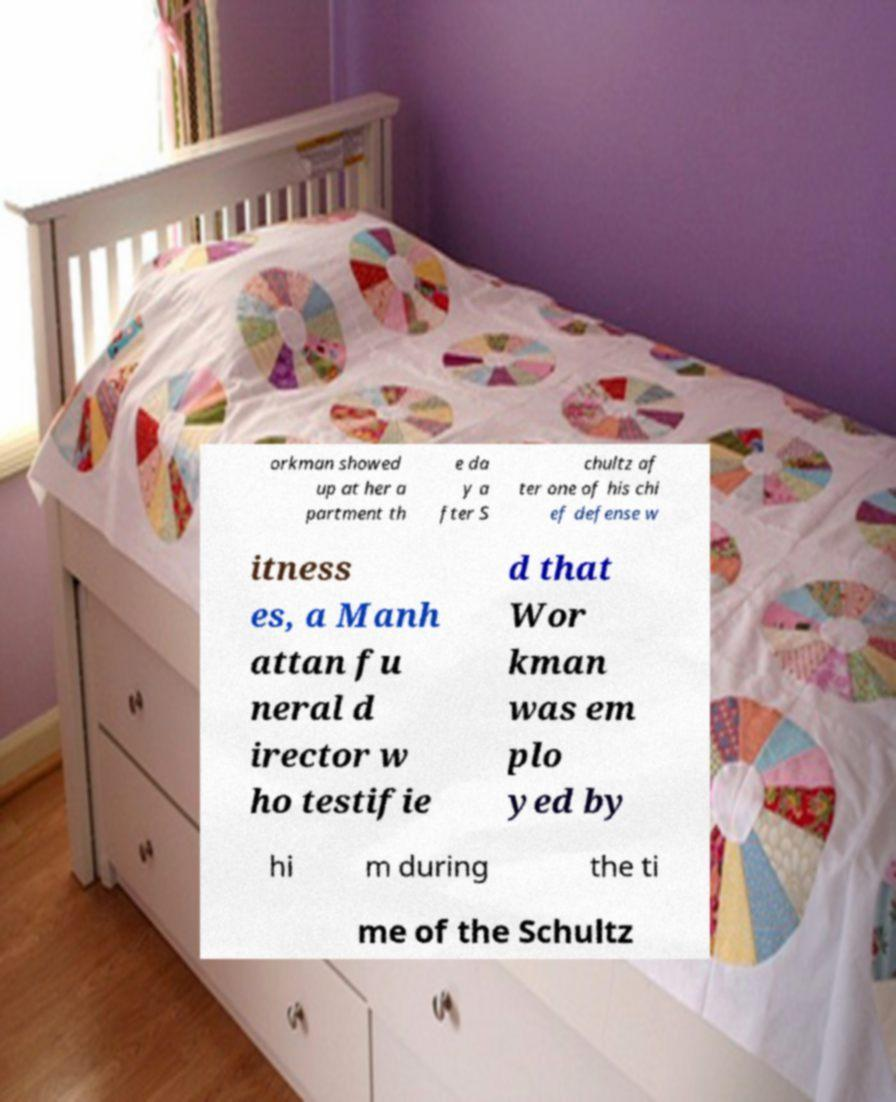Could you assist in decoding the text presented in this image and type it out clearly? orkman showed up at her a partment th e da y a fter S chultz af ter one of his chi ef defense w itness es, a Manh attan fu neral d irector w ho testifie d that Wor kman was em plo yed by hi m during the ti me of the Schultz 